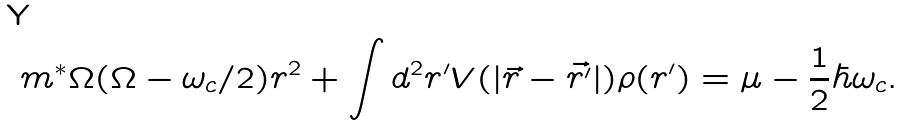Convert formula to latex. <formula><loc_0><loc_0><loc_500><loc_500>m ^ { * } \Omega ( \Omega - \omega _ { c } / 2 ) r ^ { 2 } + \int d ^ { 2 } r ^ { \prime } V ( | \vec { r } - \vec { r ^ { \prime } } | ) \rho ( r ^ { \prime } ) = \mu - \frac { 1 } { 2 } \hbar { \omega } _ { c } .</formula> 